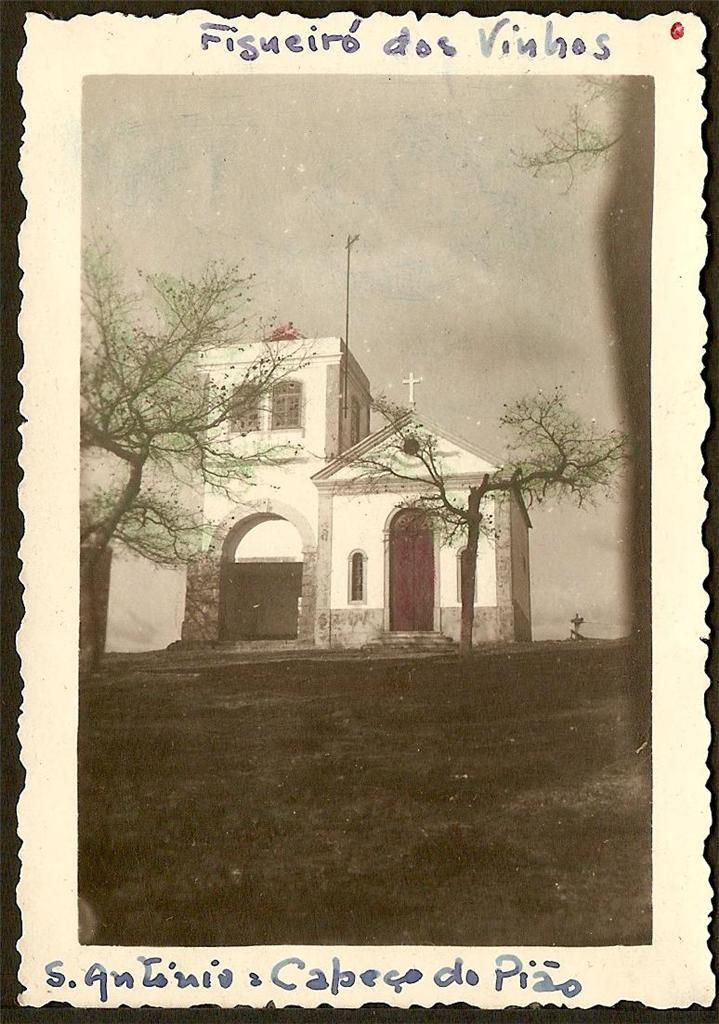<image>
Summarize the visual content of the image. Picture of an  old church with a cross on the roof and Vinhos written above the picture. 